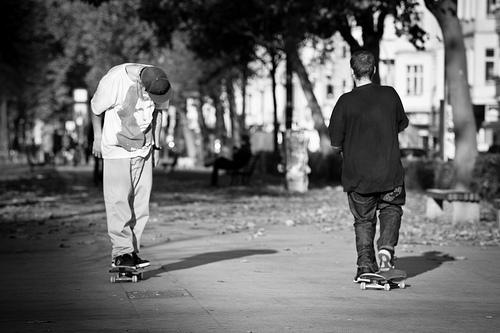Mention the central point of interest in the image and the activity it is associated with. A male skateboarder in a black shirt and jeans is skating along a wide park sidewalk. Please give a short summary of the photo, concentrating on the main activity taking place. In the photograph, a man skillfully rides his skateboard along a leaf-strewn sidewalk near park benches and trees. Briefly explain the main elements of this photograph and the actions taking place. The image focuses on a skateboarder riding his board along a tree-lined sidewalk with leaves scattered, while a person sits on a park bench nearby. Please describe the scene in the image and what is happening there. In a park setting, two skateboarders are riding along a sidewalk covered with leaves, as a man sits on a nearby bench. Express the main theme of the picture and the events unfolding. A day at the park captures a skateboarder in motion, riding alongside a leaf-covered sidewalk, while others enjoy the serenity of park benches. Outline the main components of the image and the activities occurring. The photo captures a skateboarder in motion on a sidewalk with a seated man on a park bench, surrounded by trees and fallen leaves. Write a short narration of the photo's primary character and what they're immersed in. A skateboarding enthusiast glides on his skateboard down a leaf-filled sidewalk, sharing the park with other visitors relaxing on benches. Provide a concise explanation of the image's central focus and the activity involved. The image shows a male skateboarder traversing a park sidewalk covered in leaves, with a man sitting on a bench in the background. Summarize the primary subject matter in the image and the actions being performed. A skateboarder dressed in dark clothing propels himself along a sidewalk scattered with leaves, with a man seated on a nearby park bench. Identify the primary subject of the image and describe their actions briefly. A skateboarder in a black shirt and blue jeans is captured in action as he cruises down a sidewalk in a park. 